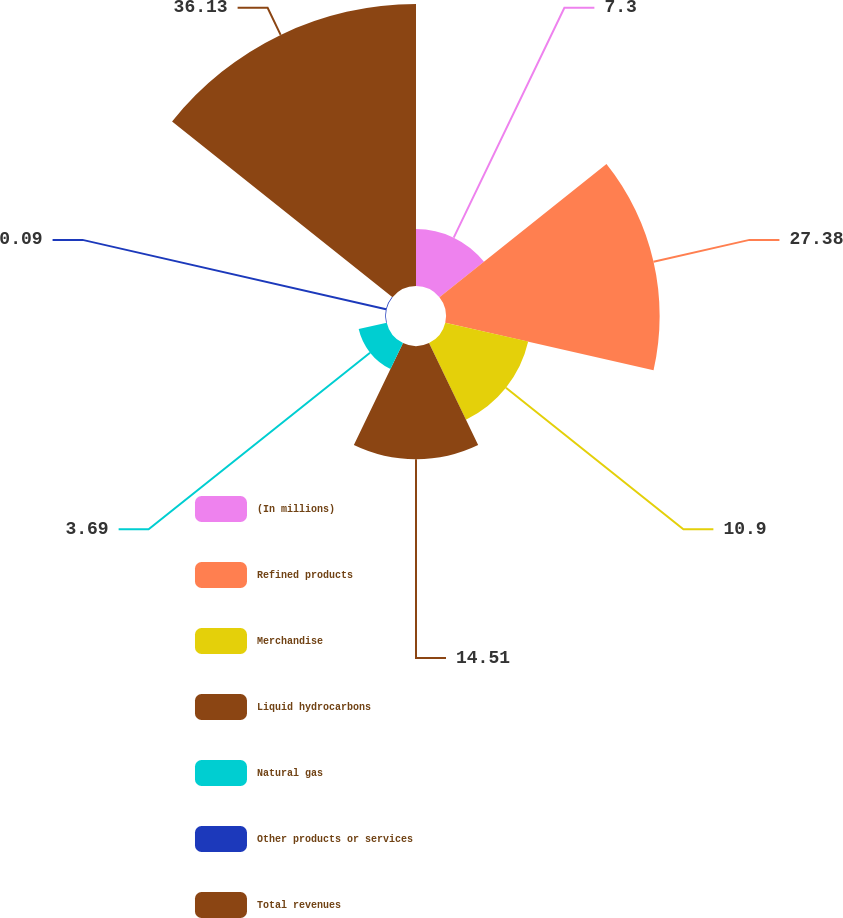Convert chart. <chart><loc_0><loc_0><loc_500><loc_500><pie_chart><fcel>(In millions)<fcel>Refined products<fcel>Merchandise<fcel>Liquid hydrocarbons<fcel>Natural gas<fcel>Other products or services<fcel>Total revenues<nl><fcel>7.3%<fcel>27.38%<fcel>10.9%<fcel>14.51%<fcel>3.69%<fcel>0.09%<fcel>36.14%<nl></chart> 